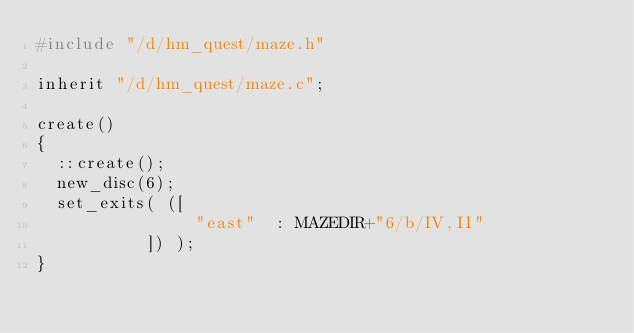Convert code to text. <code><loc_0><loc_0><loc_500><loc_500><_C_>#include "/d/hm_quest/maze.h"

inherit "/d/hm_quest/maze.c";

create()
{
  ::create();
  new_disc(6);
  set_exits( ([
                "east"  : MAZEDIR+"6/b/IV,II"
           ]) );
}

</code> 